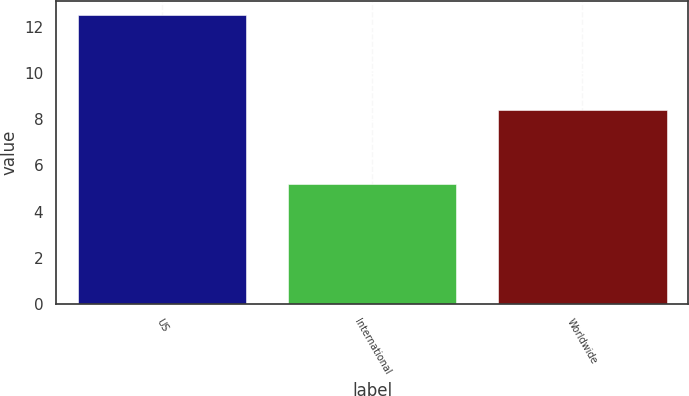Convert chart. <chart><loc_0><loc_0><loc_500><loc_500><bar_chart><fcel>US<fcel>International<fcel>Worldwide<nl><fcel>12.5<fcel>5.2<fcel>8.4<nl></chart> 